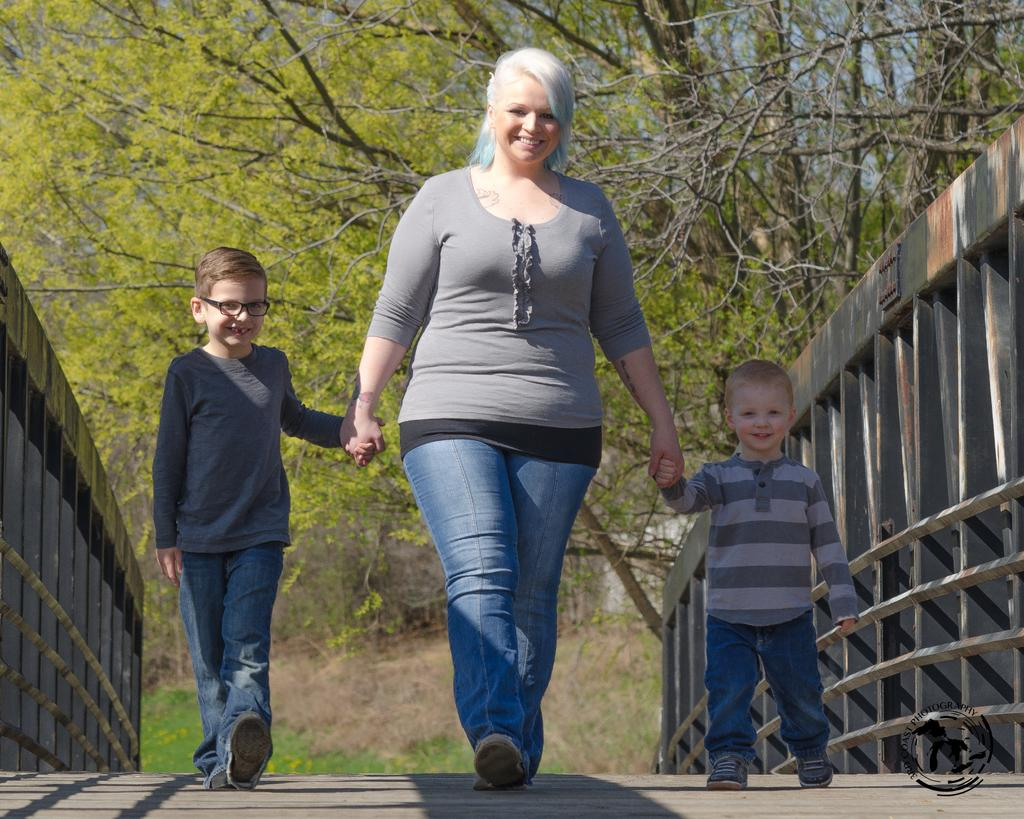Who is present in the image? There is a woman and two children in the image. What are the woman and children doing in the image? The woman and children are walking on a wooden bridge. What can be seen in the background of the image? There are trees in the background of the image. What type of detail can be seen on the brake of the woman's car in the image? There is no car present in the image, and therefore no brake or detail on a brake can be observed. 